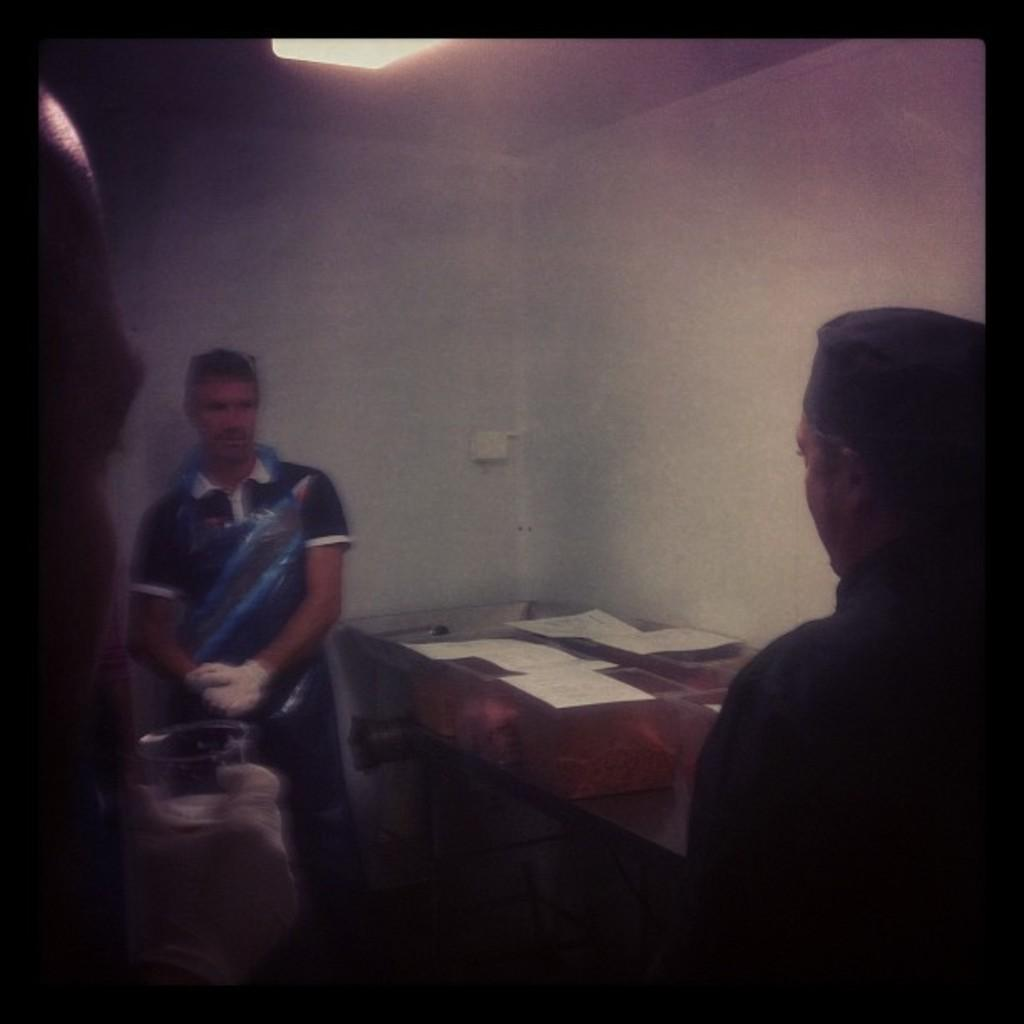What is the person holding in the image? The person is holding a glass in the image. How many people are present in the image? There are people in the image, but the exact number is not specified. What else can be seen in the image besides the people? There are boxes in the image. What is providing illumination in the image? There is a light source in the image. What type of grass is growing in the image? There is no grass present in the image. What subjects are being taught at the school in the image? There is no school present in the image. 